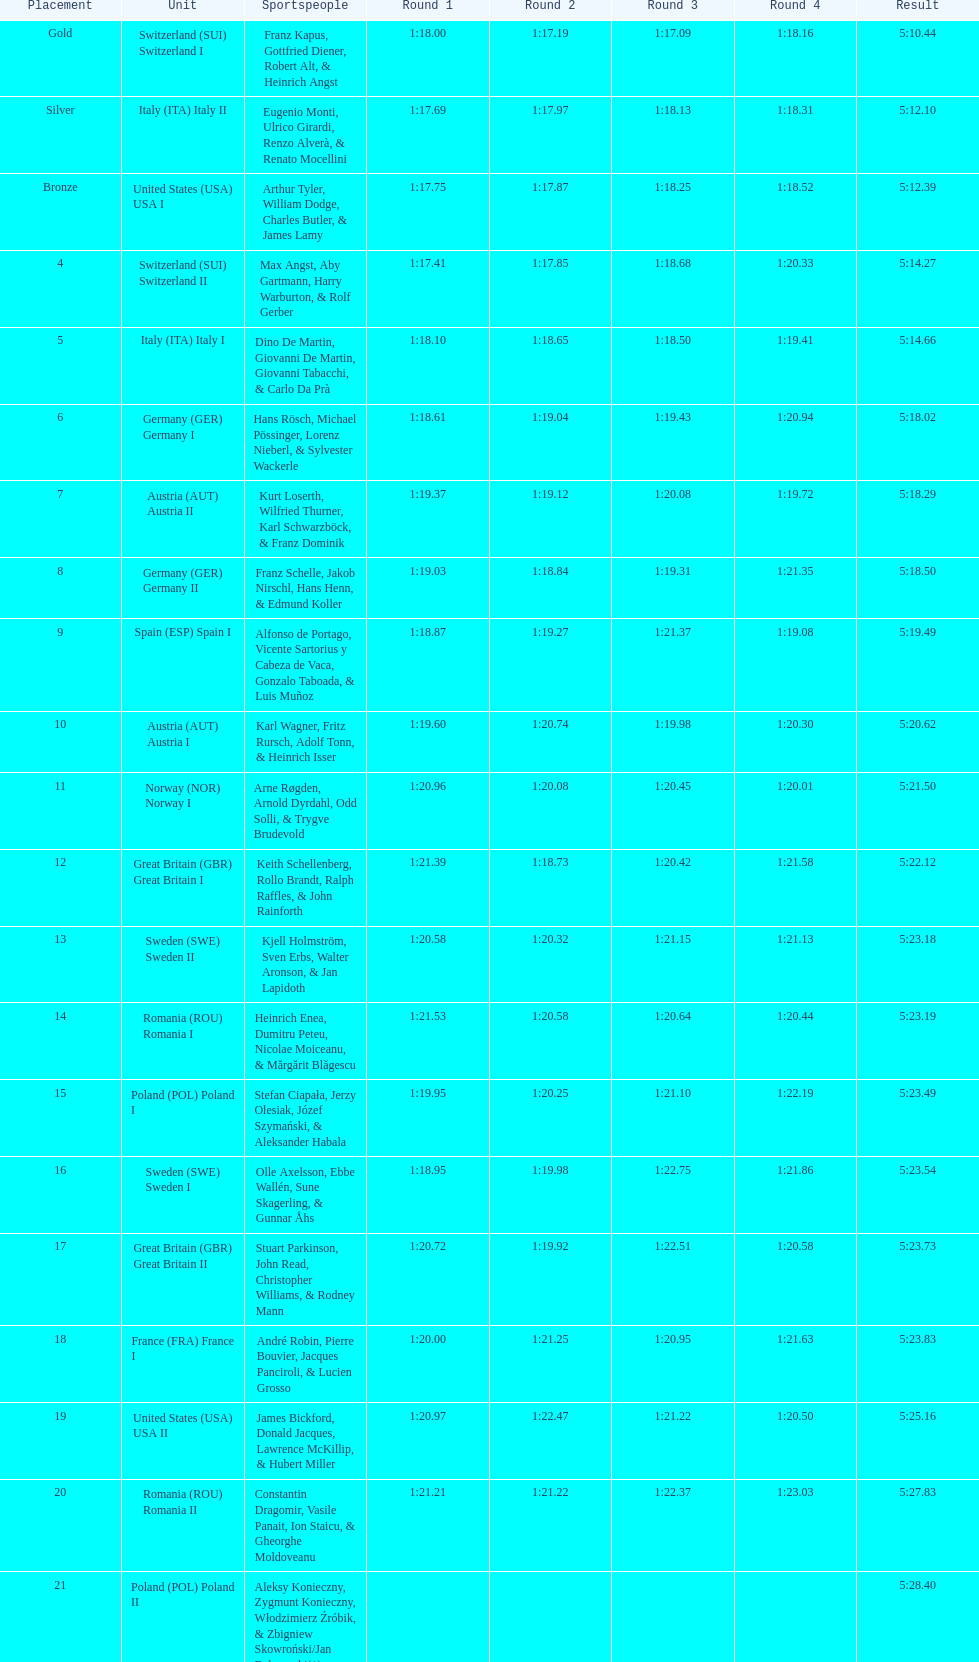Prior to italy (ita) italy ii, who was the previous team? Switzerland (SUI) Switzerland I. 